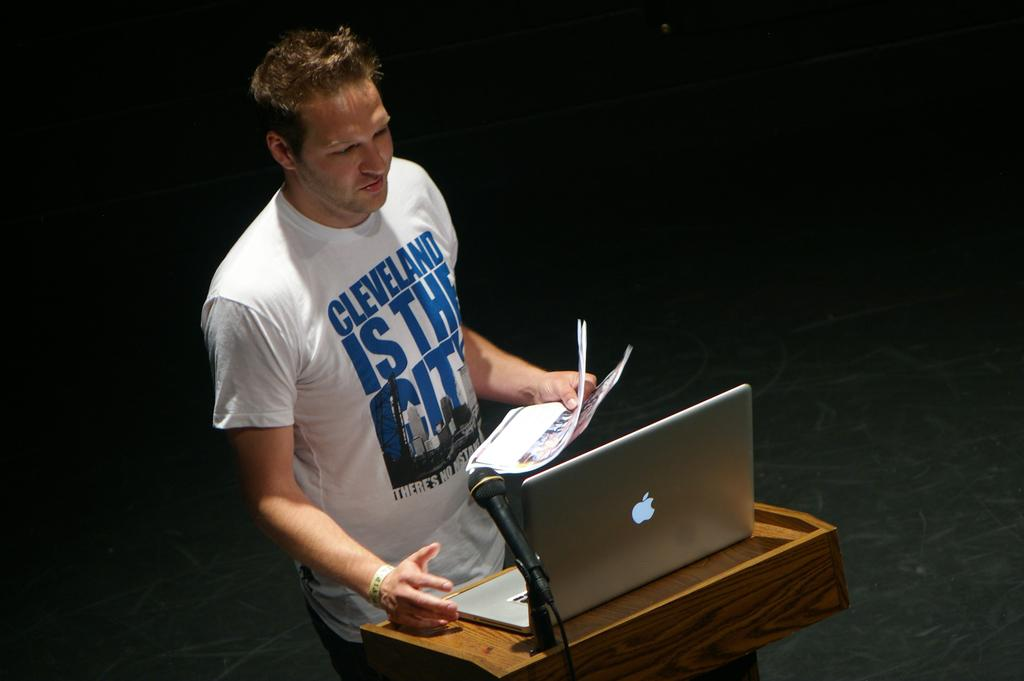<image>
Create a compact narrative representing the image presented. Man wearing a white shirt that says "Cleveland" giving a speech. 